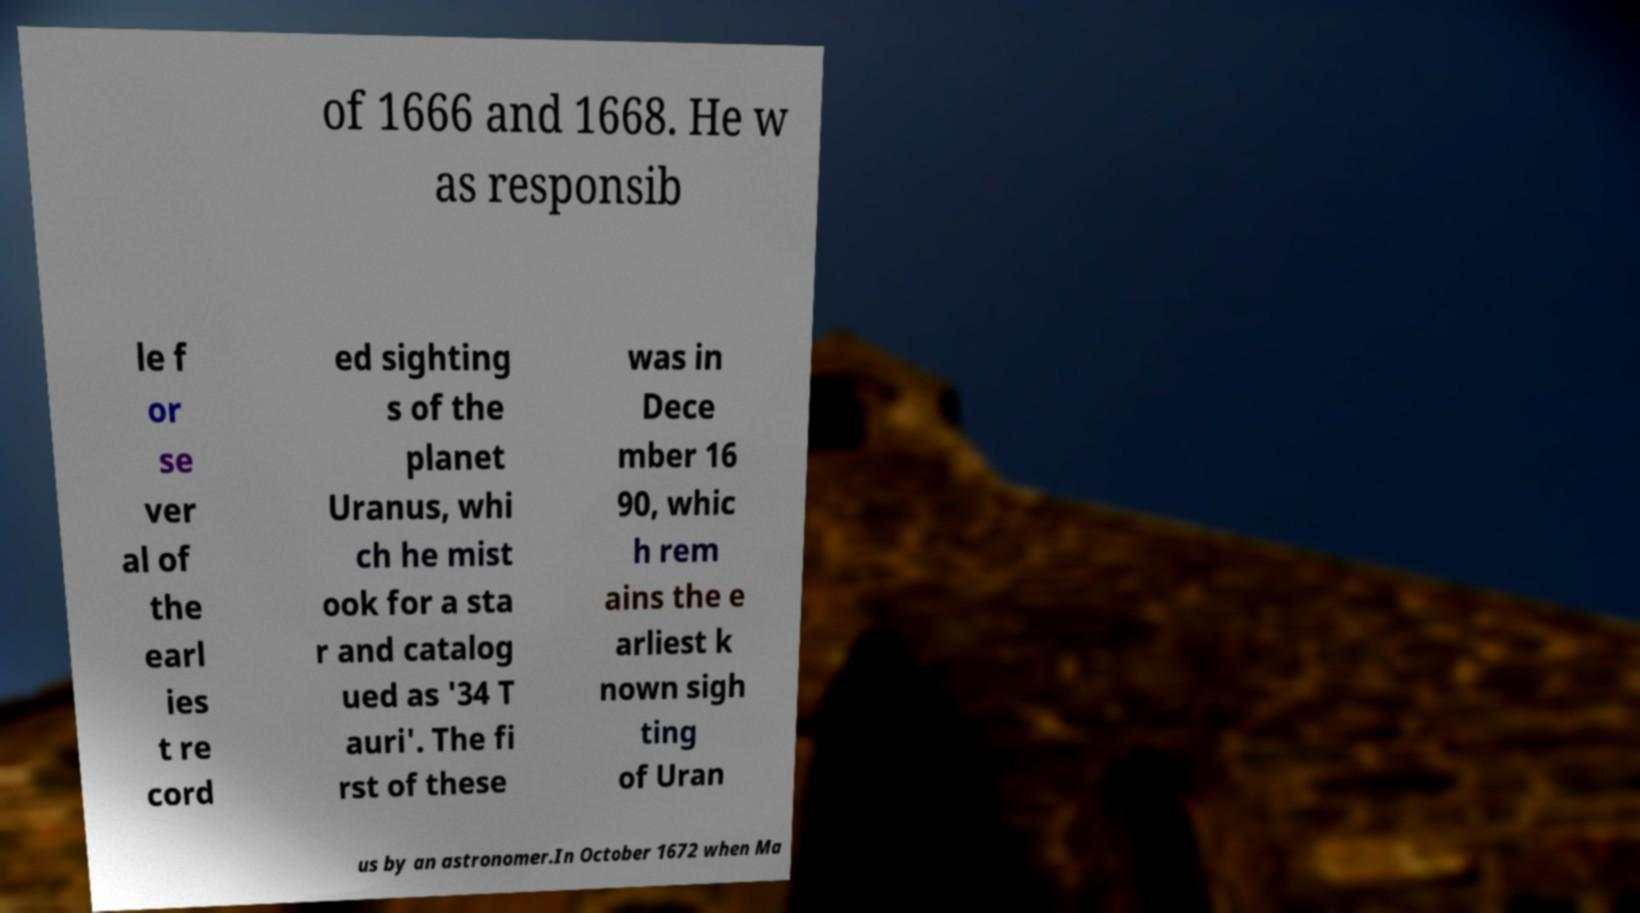Can you accurately transcribe the text from the provided image for me? of 1666 and 1668. He w as responsib le f or se ver al of the earl ies t re cord ed sighting s of the planet Uranus, whi ch he mist ook for a sta r and catalog ued as '34 T auri'. The fi rst of these was in Dece mber 16 90, whic h rem ains the e arliest k nown sigh ting of Uran us by an astronomer.In October 1672 when Ma 